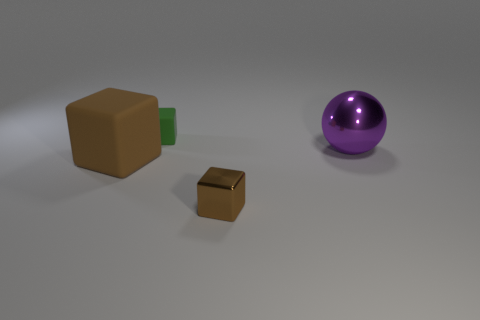What color is the big object that is right of the small object in front of the thing behind the purple metal thing?
Provide a succinct answer. Purple. Are there an equal number of brown blocks on the left side of the small brown shiny cube and tiny blocks that are in front of the big brown rubber block?
Keep it short and to the point. Yes. The thing that is the same size as the metal cube is what shape?
Your response must be concise. Cube. Are there any things of the same color as the small metal block?
Your answer should be very brief. Yes. There is a large object right of the green cube; what is its shape?
Ensure brevity in your answer.  Sphere. The large cube has what color?
Make the answer very short. Brown. The other block that is the same material as the large brown block is what color?
Offer a very short reply. Green. What number of brown objects have the same material as the purple thing?
Ensure brevity in your answer.  1. There is a green cube; how many brown things are to the right of it?
Provide a short and direct response. 1. Are the thing behind the purple metal object and the big object on the left side of the large ball made of the same material?
Your answer should be very brief. Yes. 